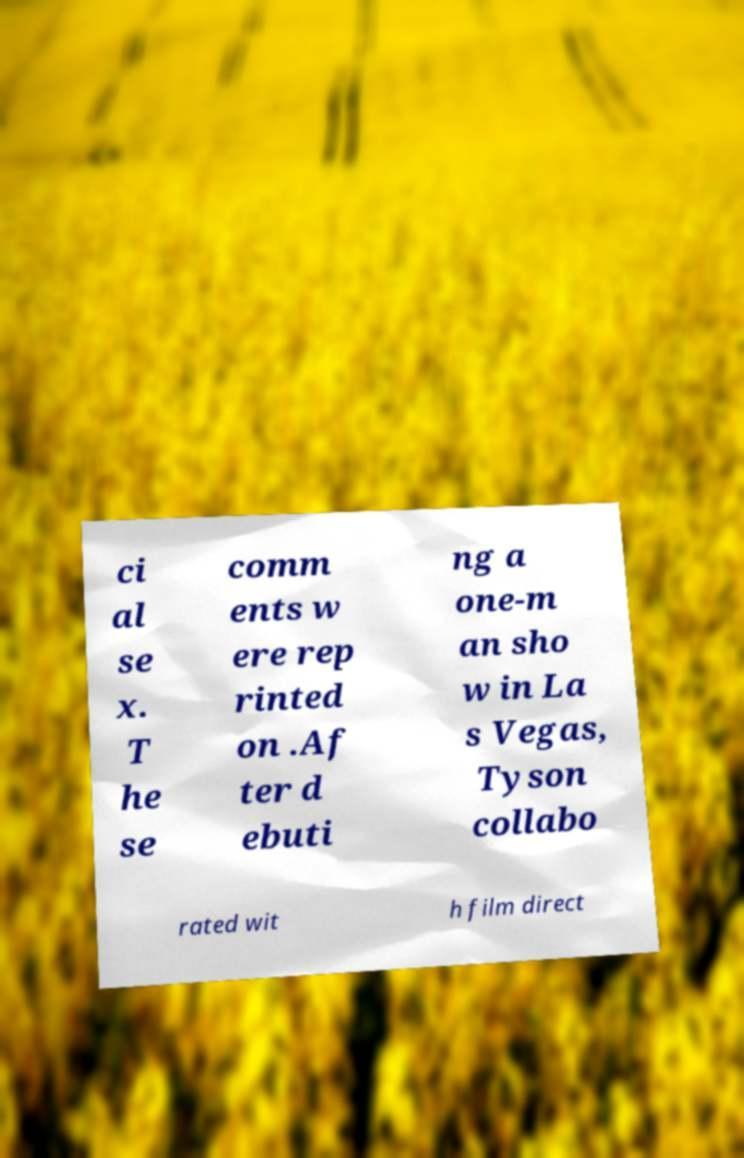What messages or text are displayed in this image? I need them in a readable, typed format. ci al se x. T he se comm ents w ere rep rinted on .Af ter d ebuti ng a one-m an sho w in La s Vegas, Tyson collabo rated wit h film direct 